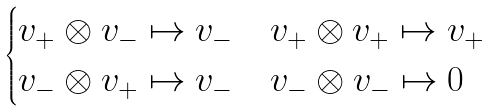<formula> <loc_0><loc_0><loc_500><loc_500>\begin{cases} v _ { + } \otimes v _ { - } \mapsto v _ { - } & v _ { + } \otimes v _ { + } \mapsto v _ { + } \\ v _ { - } \otimes v _ { + } \mapsto v _ { - } & v _ { - } \otimes v _ { - } \mapsto 0 \end{cases}</formula> 